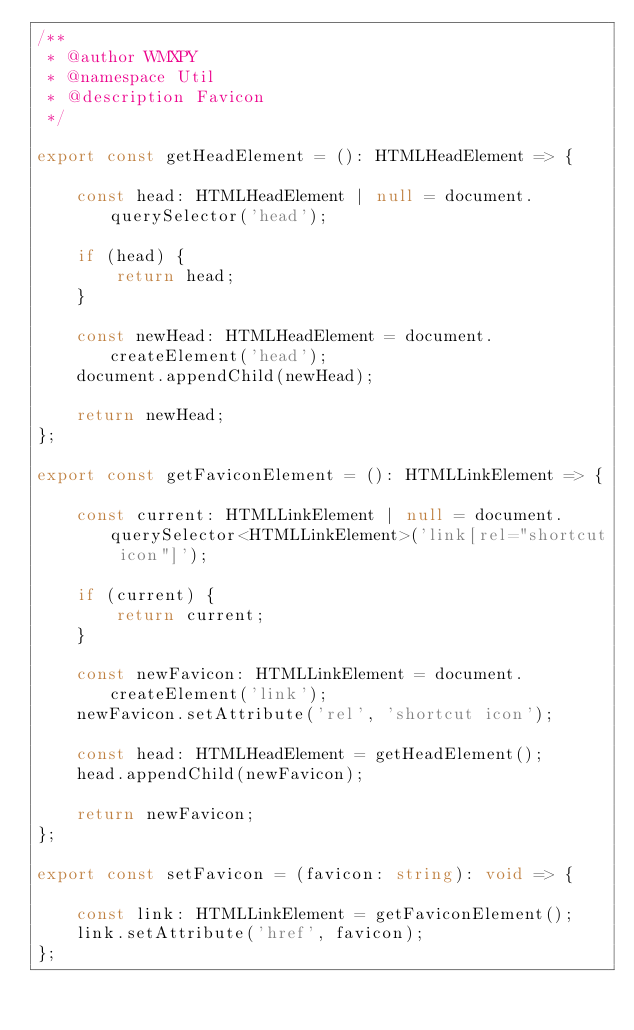<code> <loc_0><loc_0><loc_500><loc_500><_TypeScript_>/**
 * @author WMXPY
 * @namespace Util
 * @description Favicon
 */

export const getHeadElement = (): HTMLHeadElement => {

    const head: HTMLHeadElement | null = document.querySelector('head');

    if (head) {
        return head;
    }

    const newHead: HTMLHeadElement = document.createElement('head');
    document.appendChild(newHead);

    return newHead;
};

export const getFaviconElement = (): HTMLLinkElement => {

    const current: HTMLLinkElement | null = document.querySelector<HTMLLinkElement>('link[rel="shortcut icon"]');

    if (current) {
        return current;
    }

    const newFavicon: HTMLLinkElement = document.createElement('link');
    newFavicon.setAttribute('rel', 'shortcut icon');

    const head: HTMLHeadElement = getHeadElement();
    head.appendChild(newFavicon);

    return newFavicon;
};

export const setFavicon = (favicon: string): void => {

    const link: HTMLLinkElement = getFaviconElement();
    link.setAttribute('href', favicon);
};
</code> 